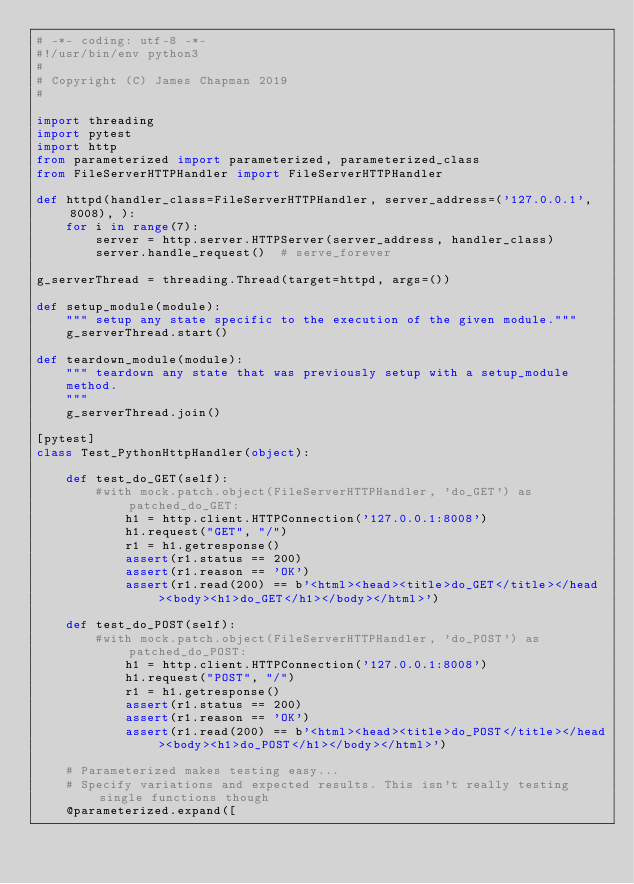Convert code to text. <code><loc_0><loc_0><loc_500><loc_500><_Python_># -*- coding: utf-8 -*-
#!/usr/bin/env python3
#
# Copyright (C) James Chapman 2019
#

import threading
import pytest
import http
from parameterized import parameterized, parameterized_class
from FileServerHTTPHandler import FileServerHTTPHandler

def httpd(handler_class=FileServerHTTPHandler, server_address=('127.0.0.1', 8008), ):
    for i in range(7):
        server = http.server.HTTPServer(server_address, handler_class)
        server.handle_request()  # serve_forever

g_serverThread = threading.Thread(target=httpd, args=())

def setup_module(module):
    """ setup any state specific to the execution of the given module."""
    g_serverThread.start()

def teardown_module(module):
    """ teardown any state that was previously setup with a setup_module
    method.
    """
    g_serverThread.join()

[pytest]
class Test_PythonHttpHandler(object):

    def test_do_GET(self):
        #with mock.patch.object(FileServerHTTPHandler, 'do_GET') as patched_do_GET:
            h1 = http.client.HTTPConnection('127.0.0.1:8008')
            h1.request("GET", "/")
            r1 = h1.getresponse()
            assert(r1.status == 200)
            assert(r1.reason == 'OK')
            assert(r1.read(200) == b'<html><head><title>do_GET</title></head><body><h1>do_GET</h1></body></html>')

    def test_do_POST(self):
        #with mock.patch.object(FileServerHTTPHandler, 'do_POST') as patched_do_POST:
            h1 = http.client.HTTPConnection('127.0.0.1:8008')
            h1.request("POST", "/")
            r1 = h1.getresponse()
            assert(r1.status == 200)
            assert(r1.reason == 'OK')
            assert(r1.read(200) == b'<html><head><title>do_POST</title></head><body><h1>do_POST</h1></body></html>')

    # Parameterized makes testing easy...
    # Specify variations and expected results. This isn't really testing single functions though
    @parameterized.expand([</code> 